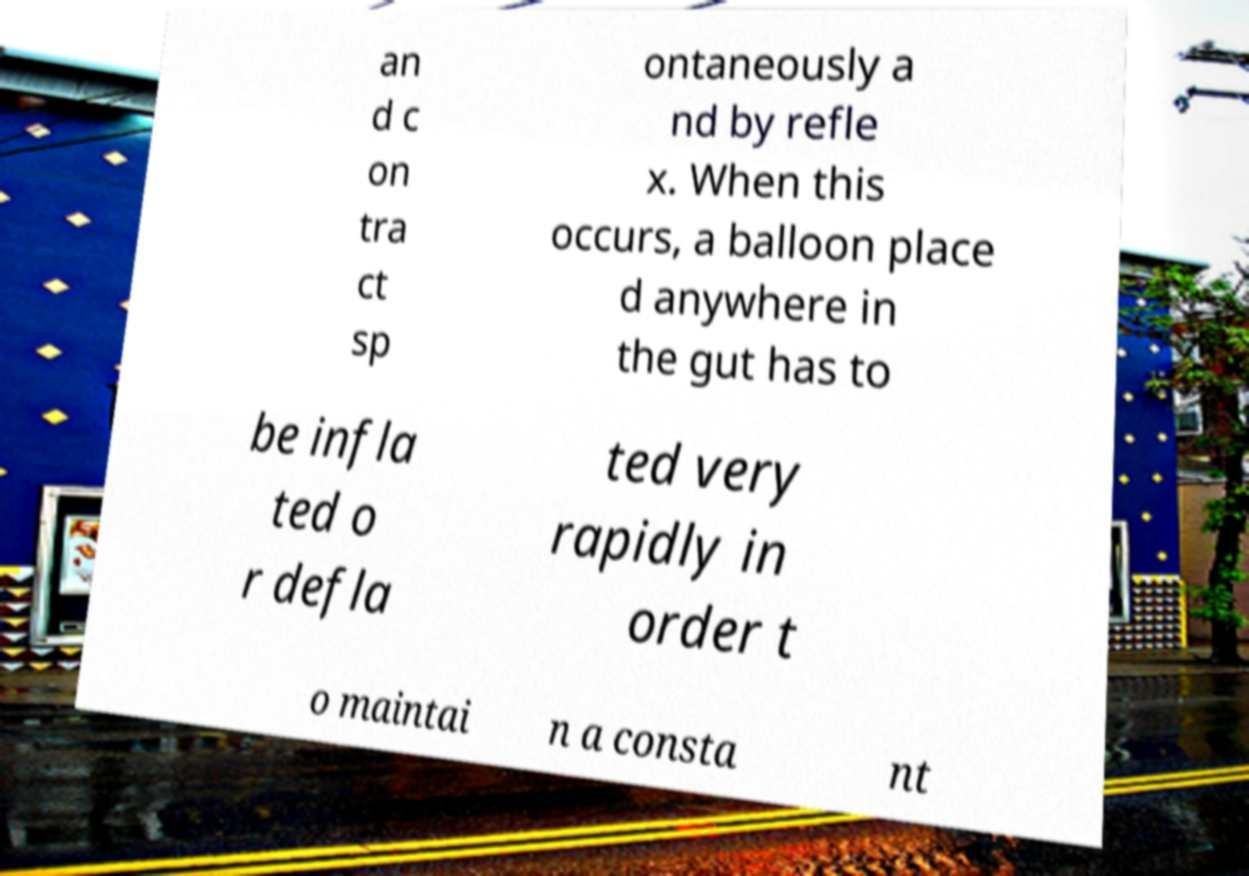Can you accurately transcribe the text from the provided image for me? an d c on tra ct sp ontaneously a nd by refle x. When this occurs, a balloon place d anywhere in the gut has to be infla ted o r defla ted very rapidly in order t o maintai n a consta nt 